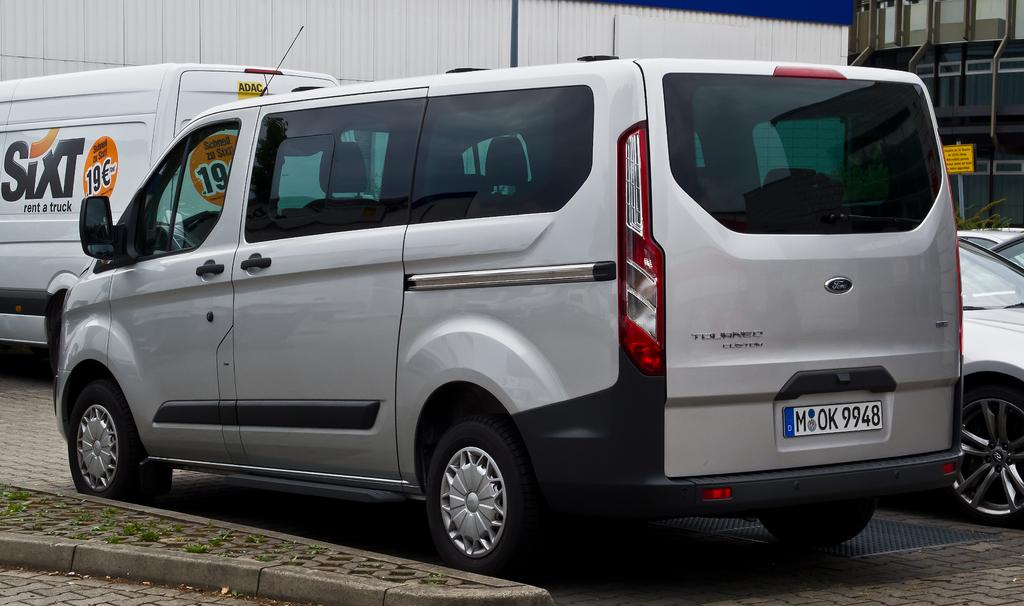<image>
Render a clear and concise summary of the photo. A gray van is parked at the curb behind a Sixt rental truck. 